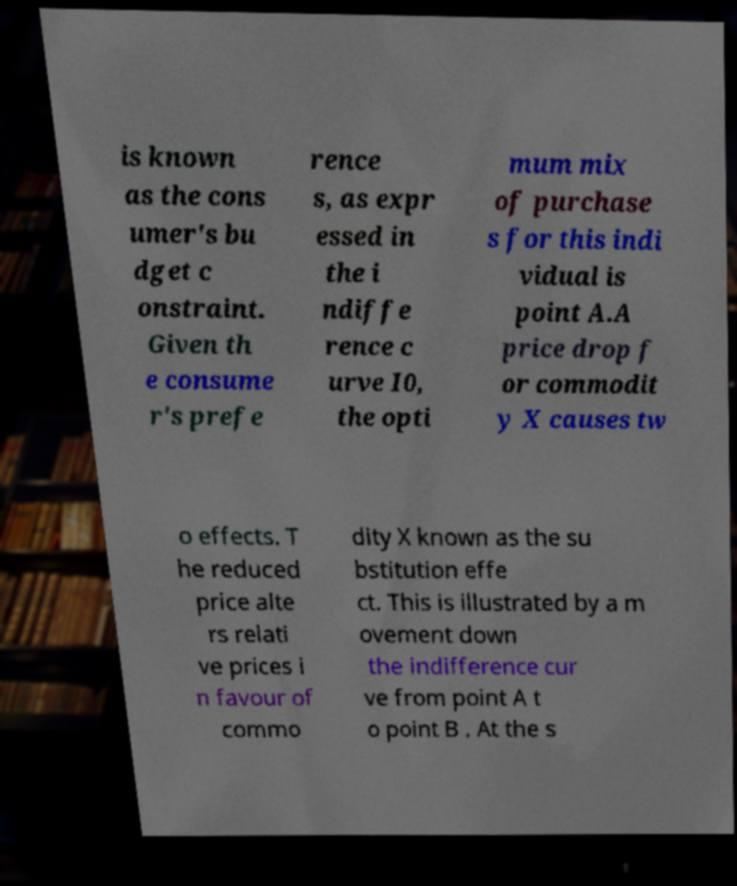For documentation purposes, I need the text within this image transcribed. Could you provide that? is known as the cons umer's bu dget c onstraint. Given th e consume r's prefe rence s, as expr essed in the i ndiffe rence c urve I0, the opti mum mix of purchase s for this indi vidual is point A.A price drop f or commodit y X causes tw o effects. T he reduced price alte rs relati ve prices i n favour of commo dity X known as the su bstitution effe ct. This is illustrated by a m ovement down the indifference cur ve from point A t o point B . At the s 